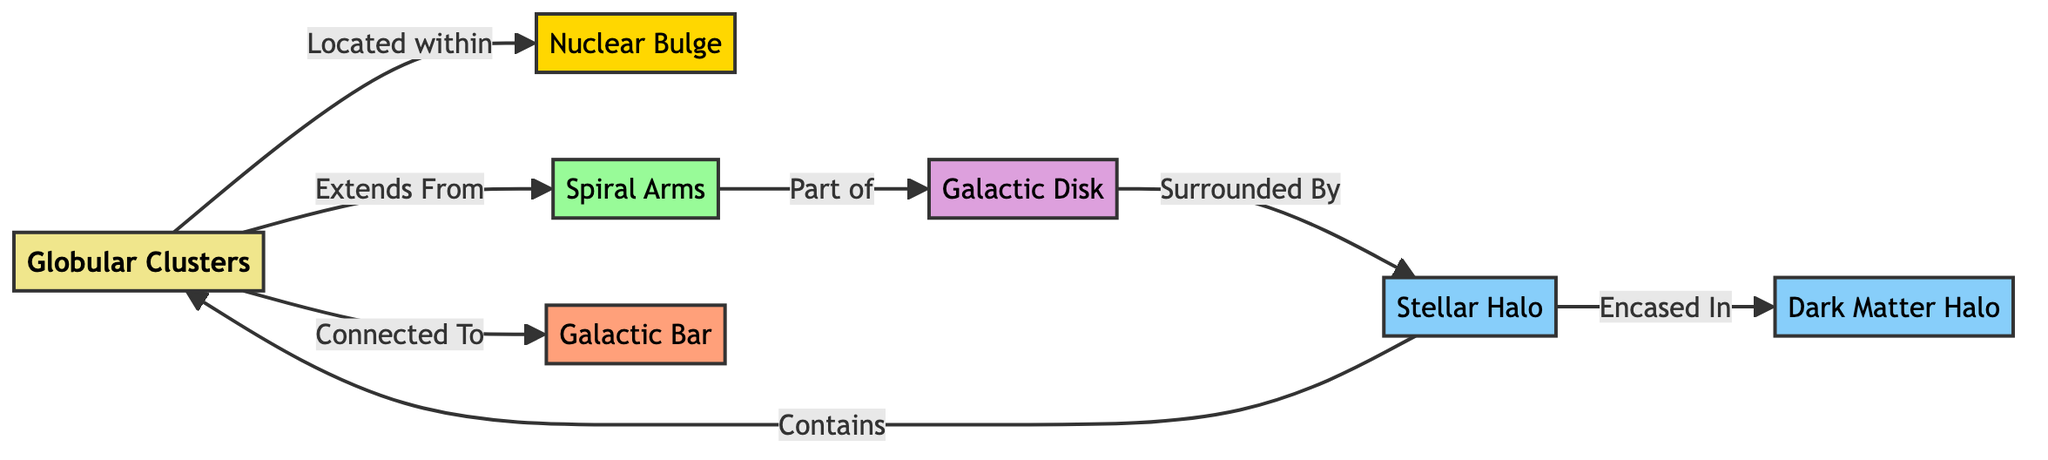What is the central component of the Milky Way? The diagram indicates that the central component is labeled as "Galactic Center." This is the starting point of the relationships indicated in the diagram.
Answer: Galactic Center How many spiral arms are in the diagram? The diagram visually represents one labeled "Spiral Arms," but it does not specify the number of arms. The information provided suggests there is one key section, which is the spiraled structure coming from the Galactic Center.
Answer: One What surrounds the Galactic Disk? According to the diagram, it states "Surrounded By" connecting the Galactic Disk to the Stellar Halo, indicating that the Stellar Halo is the outer component surrounding it.
Answer: Stellar Halo What is encased in the Dark Matter Halo? From the flow, the Stellar Halo is depicted as being encased in the Dark Matter Halo, meaning it resides within this outer structure, which encompasses the entire region.
Answer: Stellar Halo Which component is connected to the Galactic Center? The diagram shows multiple connections from the Galactic Center, including direct links to the Nuclear Bulge, Spiral Arms, and Galactic Bar. The question specifies to find one, meaning any of these can be a suitable answer.
Answer: Nuclear Bulge Which component contains the Galactic Center? The diagram indicates that the Stellar Halo "Contains" the Galactic Center, establishing that the center is located within this larger area of stars.
Answer: Stellar Halo What is the relationship between the Galactic Bar and the Galactic Center? The diagram illustrates the relationship describing that the Galactic Bar is "Connected To" the Galactic Center, indicating it is one of the neighboring structures.
Answer: Connected To Name the component that is in the inner portion of the Milky Way's structure. Based on the diagram, the inner structure can be ascertained as the "Nuclear Bulge," as it is directly linked to the Galactic Center, situated within the Milky Way formation.
Answer: Nuclear Bulge What does the Stellar Halo indicate in relation to Dark Matter? The diagram states that the Stellar Halo is "Encased In" the Dark Matter Halo. This denotes that while the Stellar Halo is an observable component, it is surrounded by the mysterious Dark Matter Halo.
Answer: Encased In 